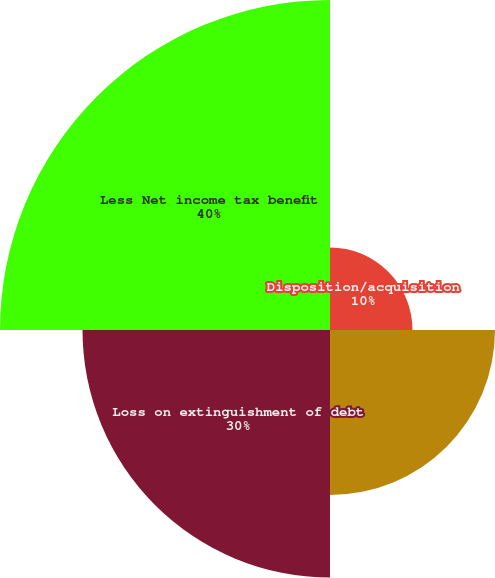<chart> <loc_0><loc_0><loc_500><loc_500><pie_chart><fcel>Disposition/acquisition<fcel>Impairment losses<fcel>Loss on extinguishment of debt<fcel>Less Net income tax benefit<nl><fcel>10.0%<fcel>20.0%<fcel>30.0%<fcel>40.0%<nl></chart> 